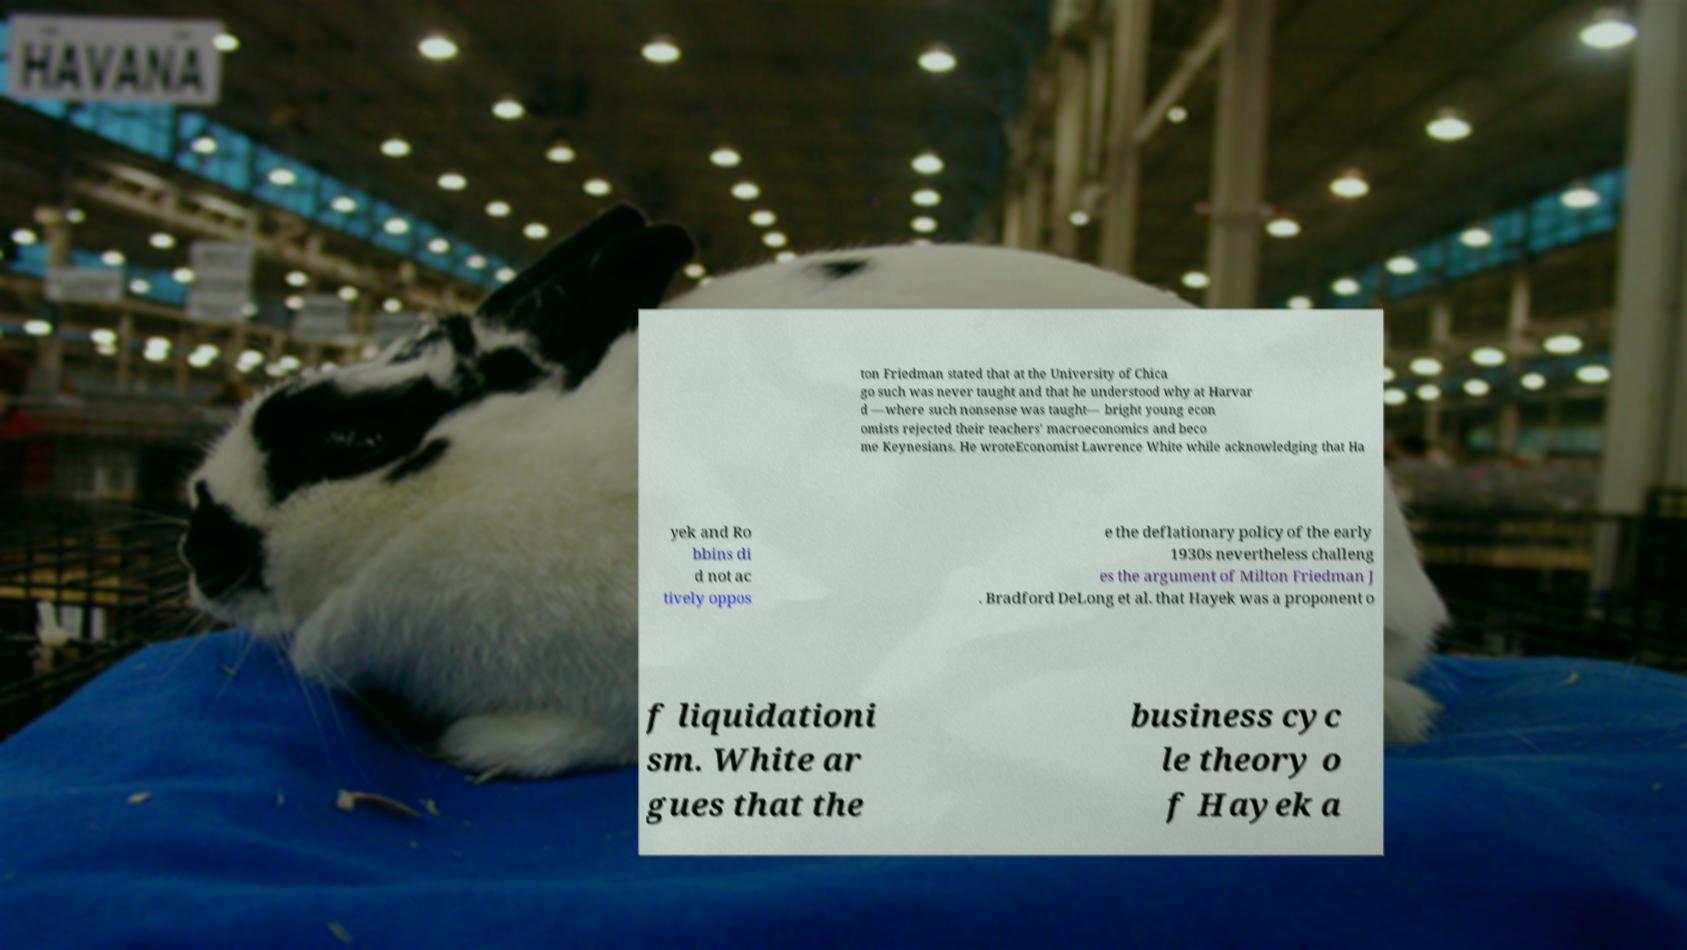What messages or text are displayed in this image? I need them in a readable, typed format. ton Friedman stated that at the University of Chica go such was never taught and that he understood why at Harvar d —where such nonsense was taught— bright young econ omists rejected their teachers' macroeconomics and beco me Keynesians. He wroteEconomist Lawrence White while acknowledging that Ha yek and Ro bbins di d not ac tively oppos e the deflationary policy of the early 1930s nevertheless challeng es the argument of Milton Friedman J . Bradford DeLong et al. that Hayek was a proponent o f liquidationi sm. White ar gues that the business cyc le theory o f Hayek a 